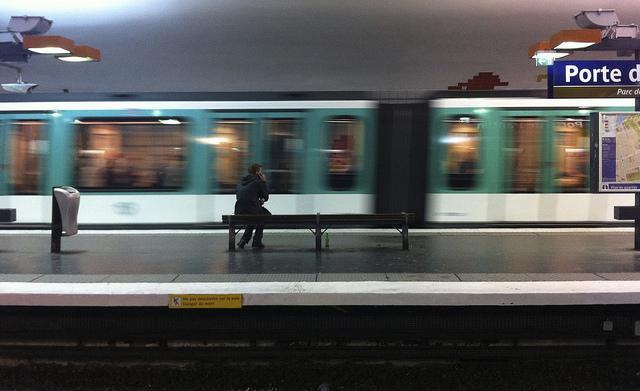How many people are sitting on the bench?
Give a very brief answer. 1. 